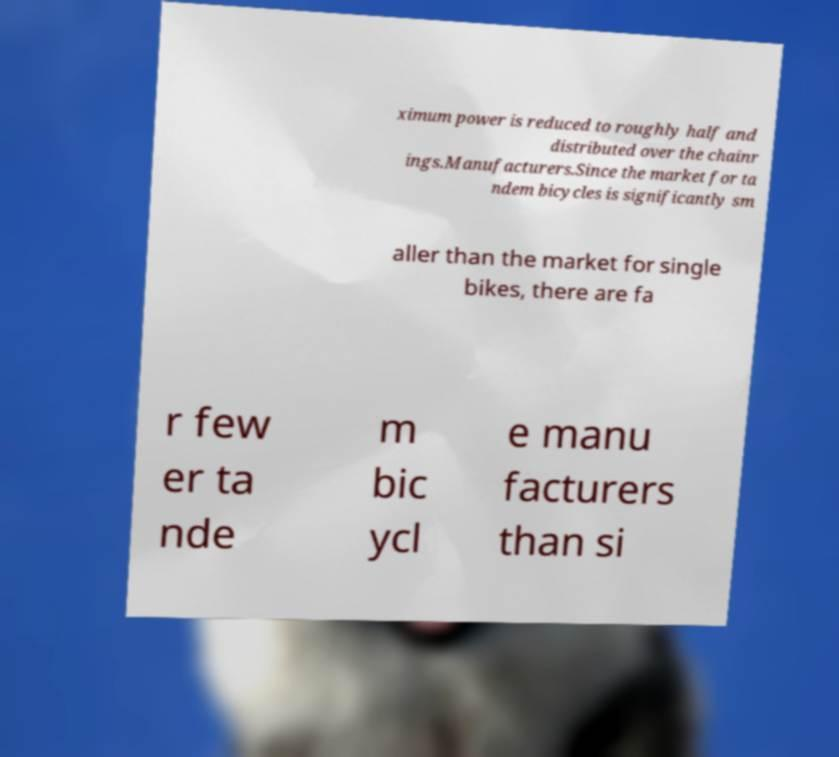Can you accurately transcribe the text from the provided image for me? ximum power is reduced to roughly half and distributed over the chainr ings.Manufacturers.Since the market for ta ndem bicycles is significantly sm aller than the market for single bikes, there are fa r few er ta nde m bic ycl e manu facturers than si 